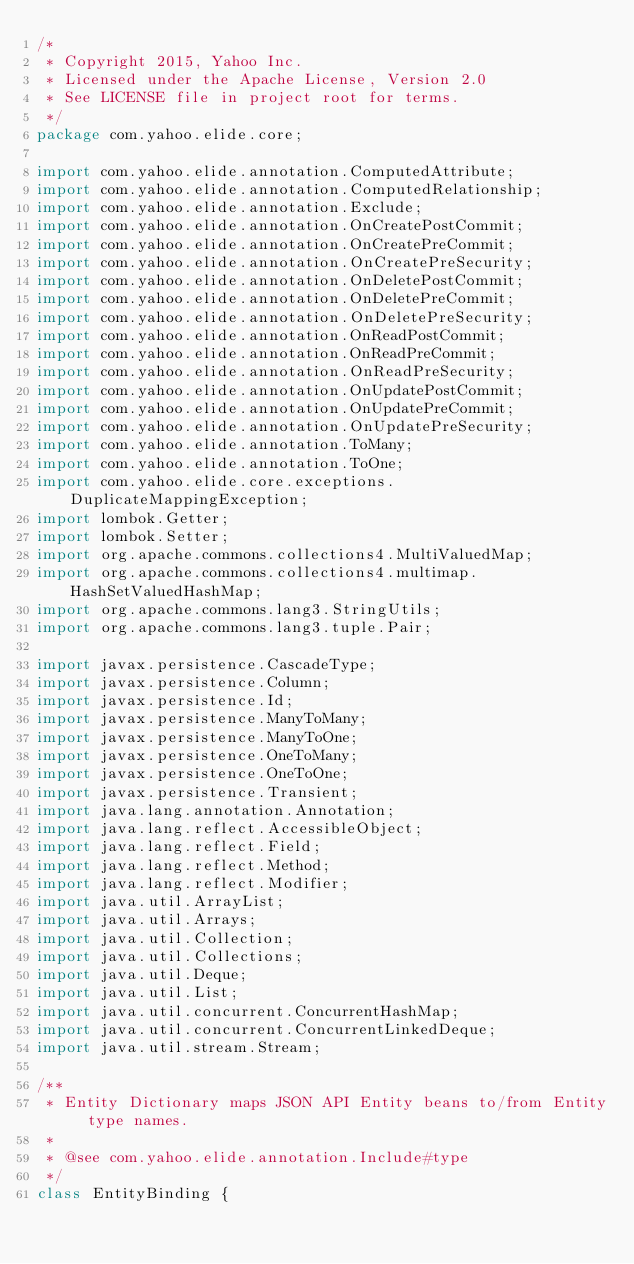<code> <loc_0><loc_0><loc_500><loc_500><_Java_>/*
 * Copyright 2015, Yahoo Inc.
 * Licensed under the Apache License, Version 2.0
 * See LICENSE file in project root for terms.
 */
package com.yahoo.elide.core;

import com.yahoo.elide.annotation.ComputedAttribute;
import com.yahoo.elide.annotation.ComputedRelationship;
import com.yahoo.elide.annotation.Exclude;
import com.yahoo.elide.annotation.OnCreatePostCommit;
import com.yahoo.elide.annotation.OnCreatePreCommit;
import com.yahoo.elide.annotation.OnCreatePreSecurity;
import com.yahoo.elide.annotation.OnDeletePostCommit;
import com.yahoo.elide.annotation.OnDeletePreCommit;
import com.yahoo.elide.annotation.OnDeletePreSecurity;
import com.yahoo.elide.annotation.OnReadPostCommit;
import com.yahoo.elide.annotation.OnReadPreCommit;
import com.yahoo.elide.annotation.OnReadPreSecurity;
import com.yahoo.elide.annotation.OnUpdatePostCommit;
import com.yahoo.elide.annotation.OnUpdatePreCommit;
import com.yahoo.elide.annotation.OnUpdatePreSecurity;
import com.yahoo.elide.annotation.ToMany;
import com.yahoo.elide.annotation.ToOne;
import com.yahoo.elide.core.exceptions.DuplicateMappingException;
import lombok.Getter;
import lombok.Setter;
import org.apache.commons.collections4.MultiValuedMap;
import org.apache.commons.collections4.multimap.HashSetValuedHashMap;
import org.apache.commons.lang3.StringUtils;
import org.apache.commons.lang3.tuple.Pair;

import javax.persistence.CascadeType;
import javax.persistence.Column;
import javax.persistence.Id;
import javax.persistence.ManyToMany;
import javax.persistence.ManyToOne;
import javax.persistence.OneToMany;
import javax.persistence.OneToOne;
import javax.persistence.Transient;
import java.lang.annotation.Annotation;
import java.lang.reflect.AccessibleObject;
import java.lang.reflect.Field;
import java.lang.reflect.Method;
import java.lang.reflect.Modifier;
import java.util.ArrayList;
import java.util.Arrays;
import java.util.Collection;
import java.util.Collections;
import java.util.Deque;
import java.util.List;
import java.util.concurrent.ConcurrentHashMap;
import java.util.concurrent.ConcurrentLinkedDeque;
import java.util.stream.Stream;

/**
 * Entity Dictionary maps JSON API Entity beans to/from Entity type names.
 *
 * @see com.yahoo.elide.annotation.Include#type
 */
class EntityBinding {
</code> 